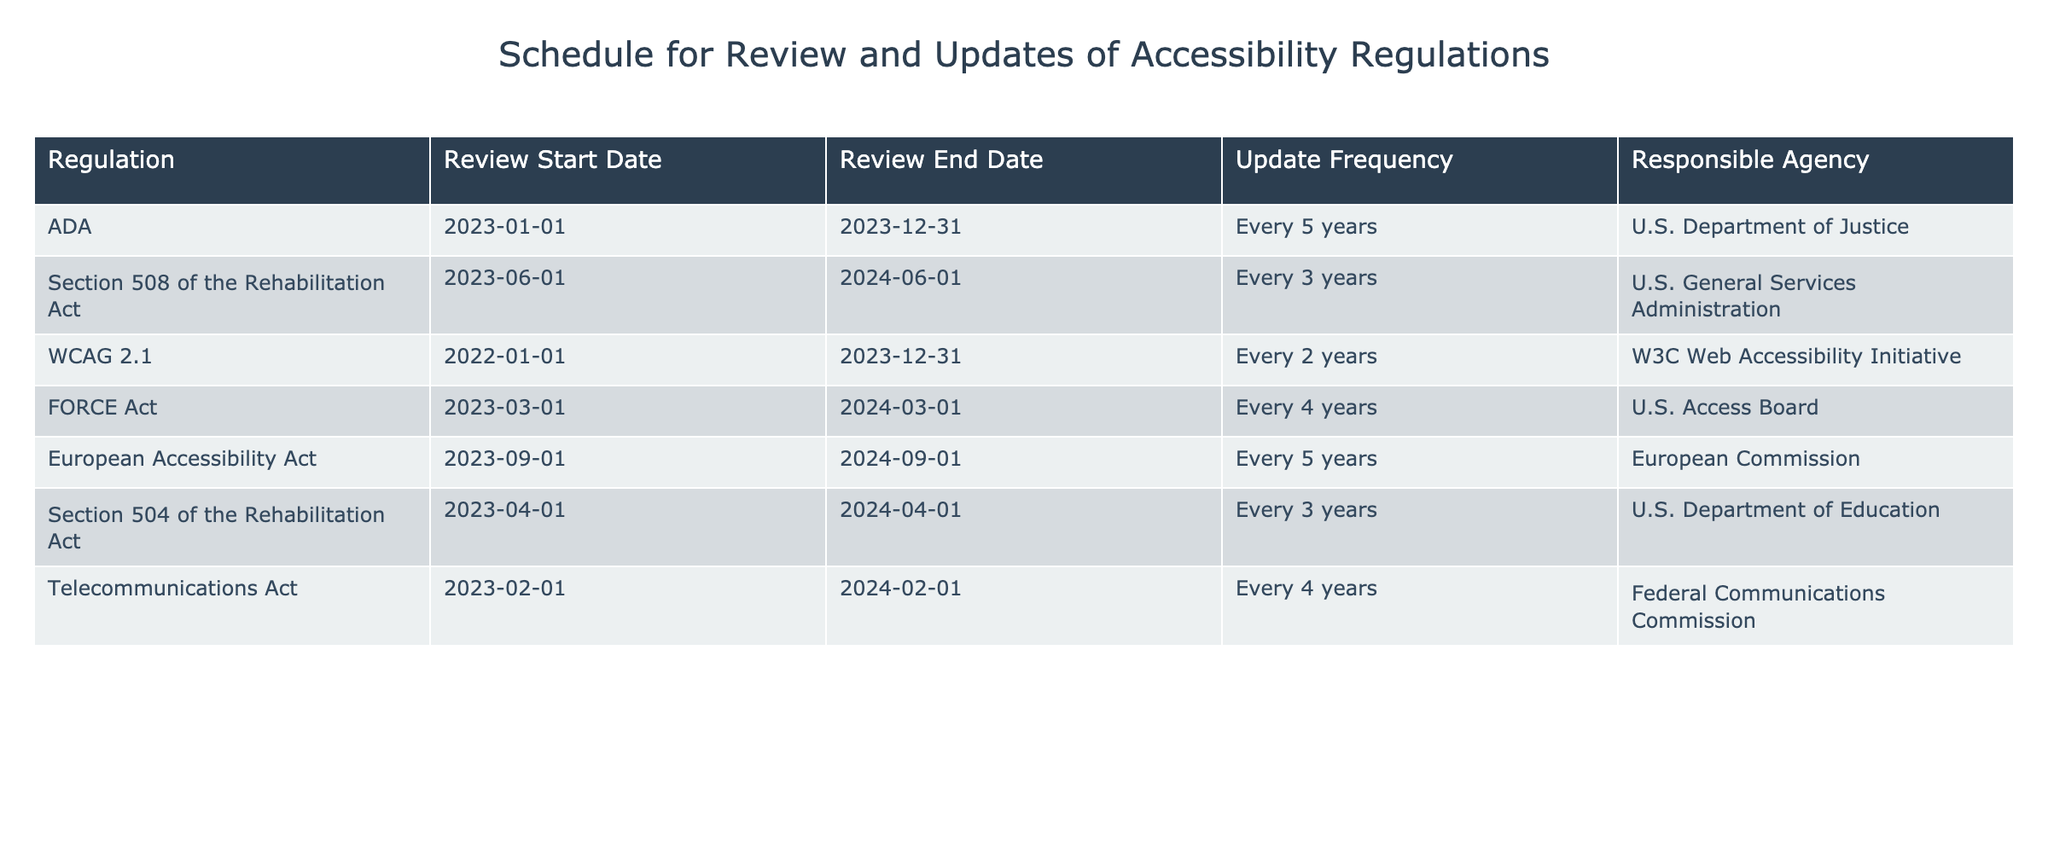What is the responsible agency for the WCAG 2.1 regulation? The table lists the responsible agency for each regulation. By finding the row for WCAG 2.1, I see that the responsible agency is the W3C Web Accessibility Initiative.
Answer: W3C Web Accessibility Initiative When does the review for the FORCE Act end? The table shows the review dates for each regulation. Looking at the row for the FORCE Act, the review end date is March 1, 2024.
Answer: March 1, 2024 Which regulation has the shortest review duration? To find the shortest review duration, I need to compare the review periods of all regulations. The ADA has a review from January 1, 2023, to December 31, 2023, which is 1 year; Section 508 of the Rehabilitation Act has a duration of 1 year from June 1, 2023, to June 1, 2024; other regulations have longer durations. Therefore, the ADA has the shortest duration at 1 year.
Answer: ADA Is the European Accessibility Act reviewed every 5 years? The table clearly states the update frequency for each regulation. Checking the European Accessibility Act shows that its update frequency is indeed listed as every 5 years, confirming the statement is true.
Answer: Yes What is the average update frequency in years for all regulations listed? The update frequency in years can be summarized by converting each frequency into numerical values: ADA (5), Section 508 (3), WCAG 2.1 (2), FORCE Act (4), European Accessibility Act (5), Section 504 (3), and Telecommunications Act (4). Adding these values gives a total of 26 years over 7 regulations. Dividing by 7 gives an average of approximately 3.71 years.
Answer: 3.71 years How many regulations are reviewed by the U.S. Department of Education? I can count the rows in the table where the responsible agency is the U.S. Department of Education. There is only one regulation listed under this agency, which is Section 504 of the Rehabilitation Act.
Answer: 1 Which regulation has the longest review period and what is that duration? To find the longest review period, I will look at the review start and end dates for each regulation. The ADA lasts from January 1, 2023, to December 31, 2023; Section 508 lasts from June 1, 2023, to June 1, 2024; others have varying degrees. The longest review period is for the ADA, which is 1 year as well, but Section 508 lasts for exactly a year too. Therefore, both are equal.
Answer: ADA and Section 508 (1 year) How many agencies review regulations every 4 years? This question requires checking the table for regulations with an update frequency of every 4 years. Looking through the rows, there are two regulations: the FORCE Act and the Telecommunications Act, which are both reviewed every 4 years. Hence, there are 2 agencies involved in this frequency.
Answer: 2 